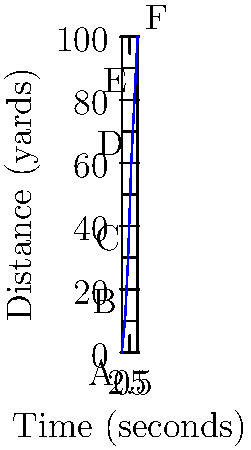During a crucial play in the championship game, you sprinted downfield as shown in the distance-time graph above. What was your average speed, in yards per second, for the entire 5-second play? To find the average speed, we need to calculate the total distance traveled and divide it by the total time taken.

1. Total distance:
   The final position (F) shows 100 yards traveled.

2. Total time:
   The play lasted 5 seconds.

3. Average speed formula:
   $$ \text{Average Speed} = \frac{\text{Total Distance}}{\text{Total Time}} $$

4. Plugging in the values:
   $$ \text{Average Speed} = \frac{100 \text{ yards}}{5 \text{ seconds}} = 20 \text{ yards/second} $$

Therefore, your average speed for the entire play was 20 yards per second.
Answer: 20 yards/second 